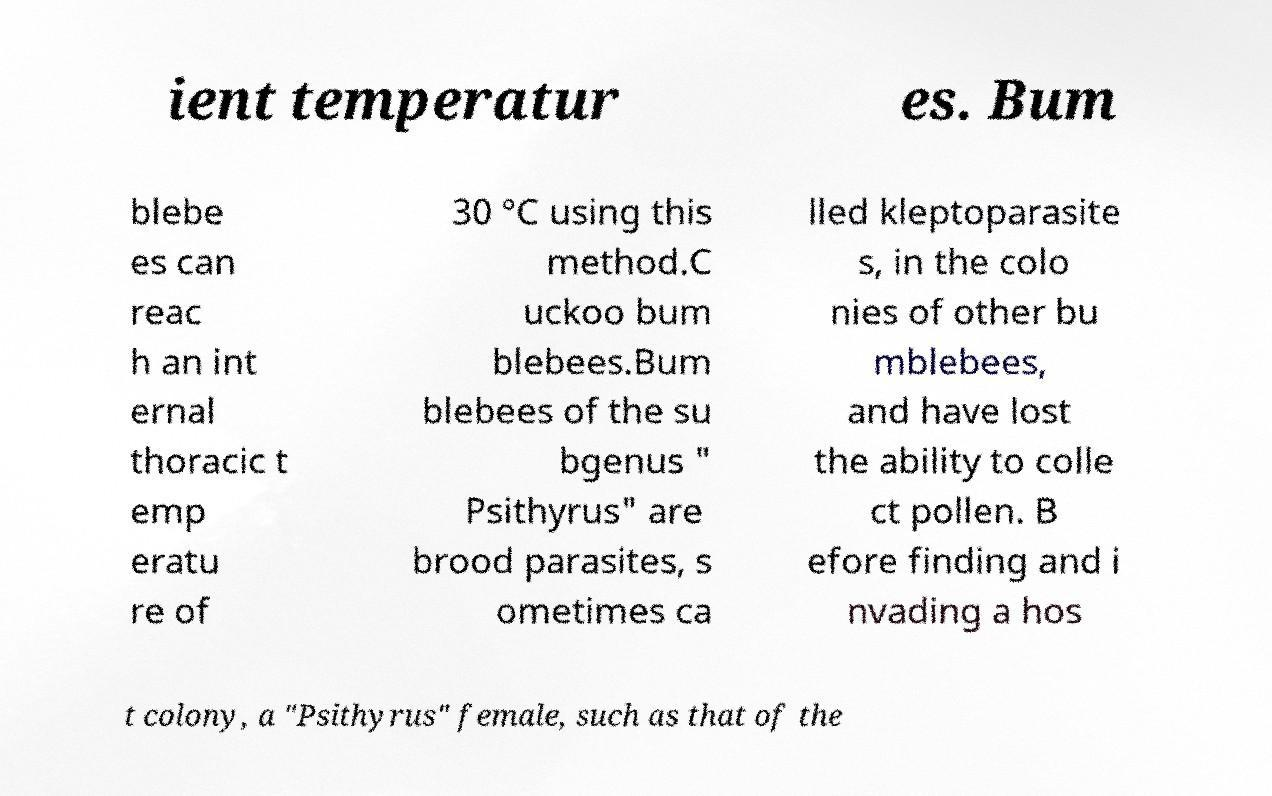For documentation purposes, I need the text within this image transcribed. Could you provide that? ient temperatur es. Bum blebe es can reac h an int ernal thoracic t emp eratu re of 30 °C using this method.C uckoo bum blebees.Bum blebees of the su bgenus " Psithyrus" are brood parasites, s ometimes ca lled kleptoparasite s, in the colo nies of other bu mblebees, and have lost the ability to colle ct pollen. B efore finding and i nvading a hos t colony, a "Psithyrus" female, such as that of the 